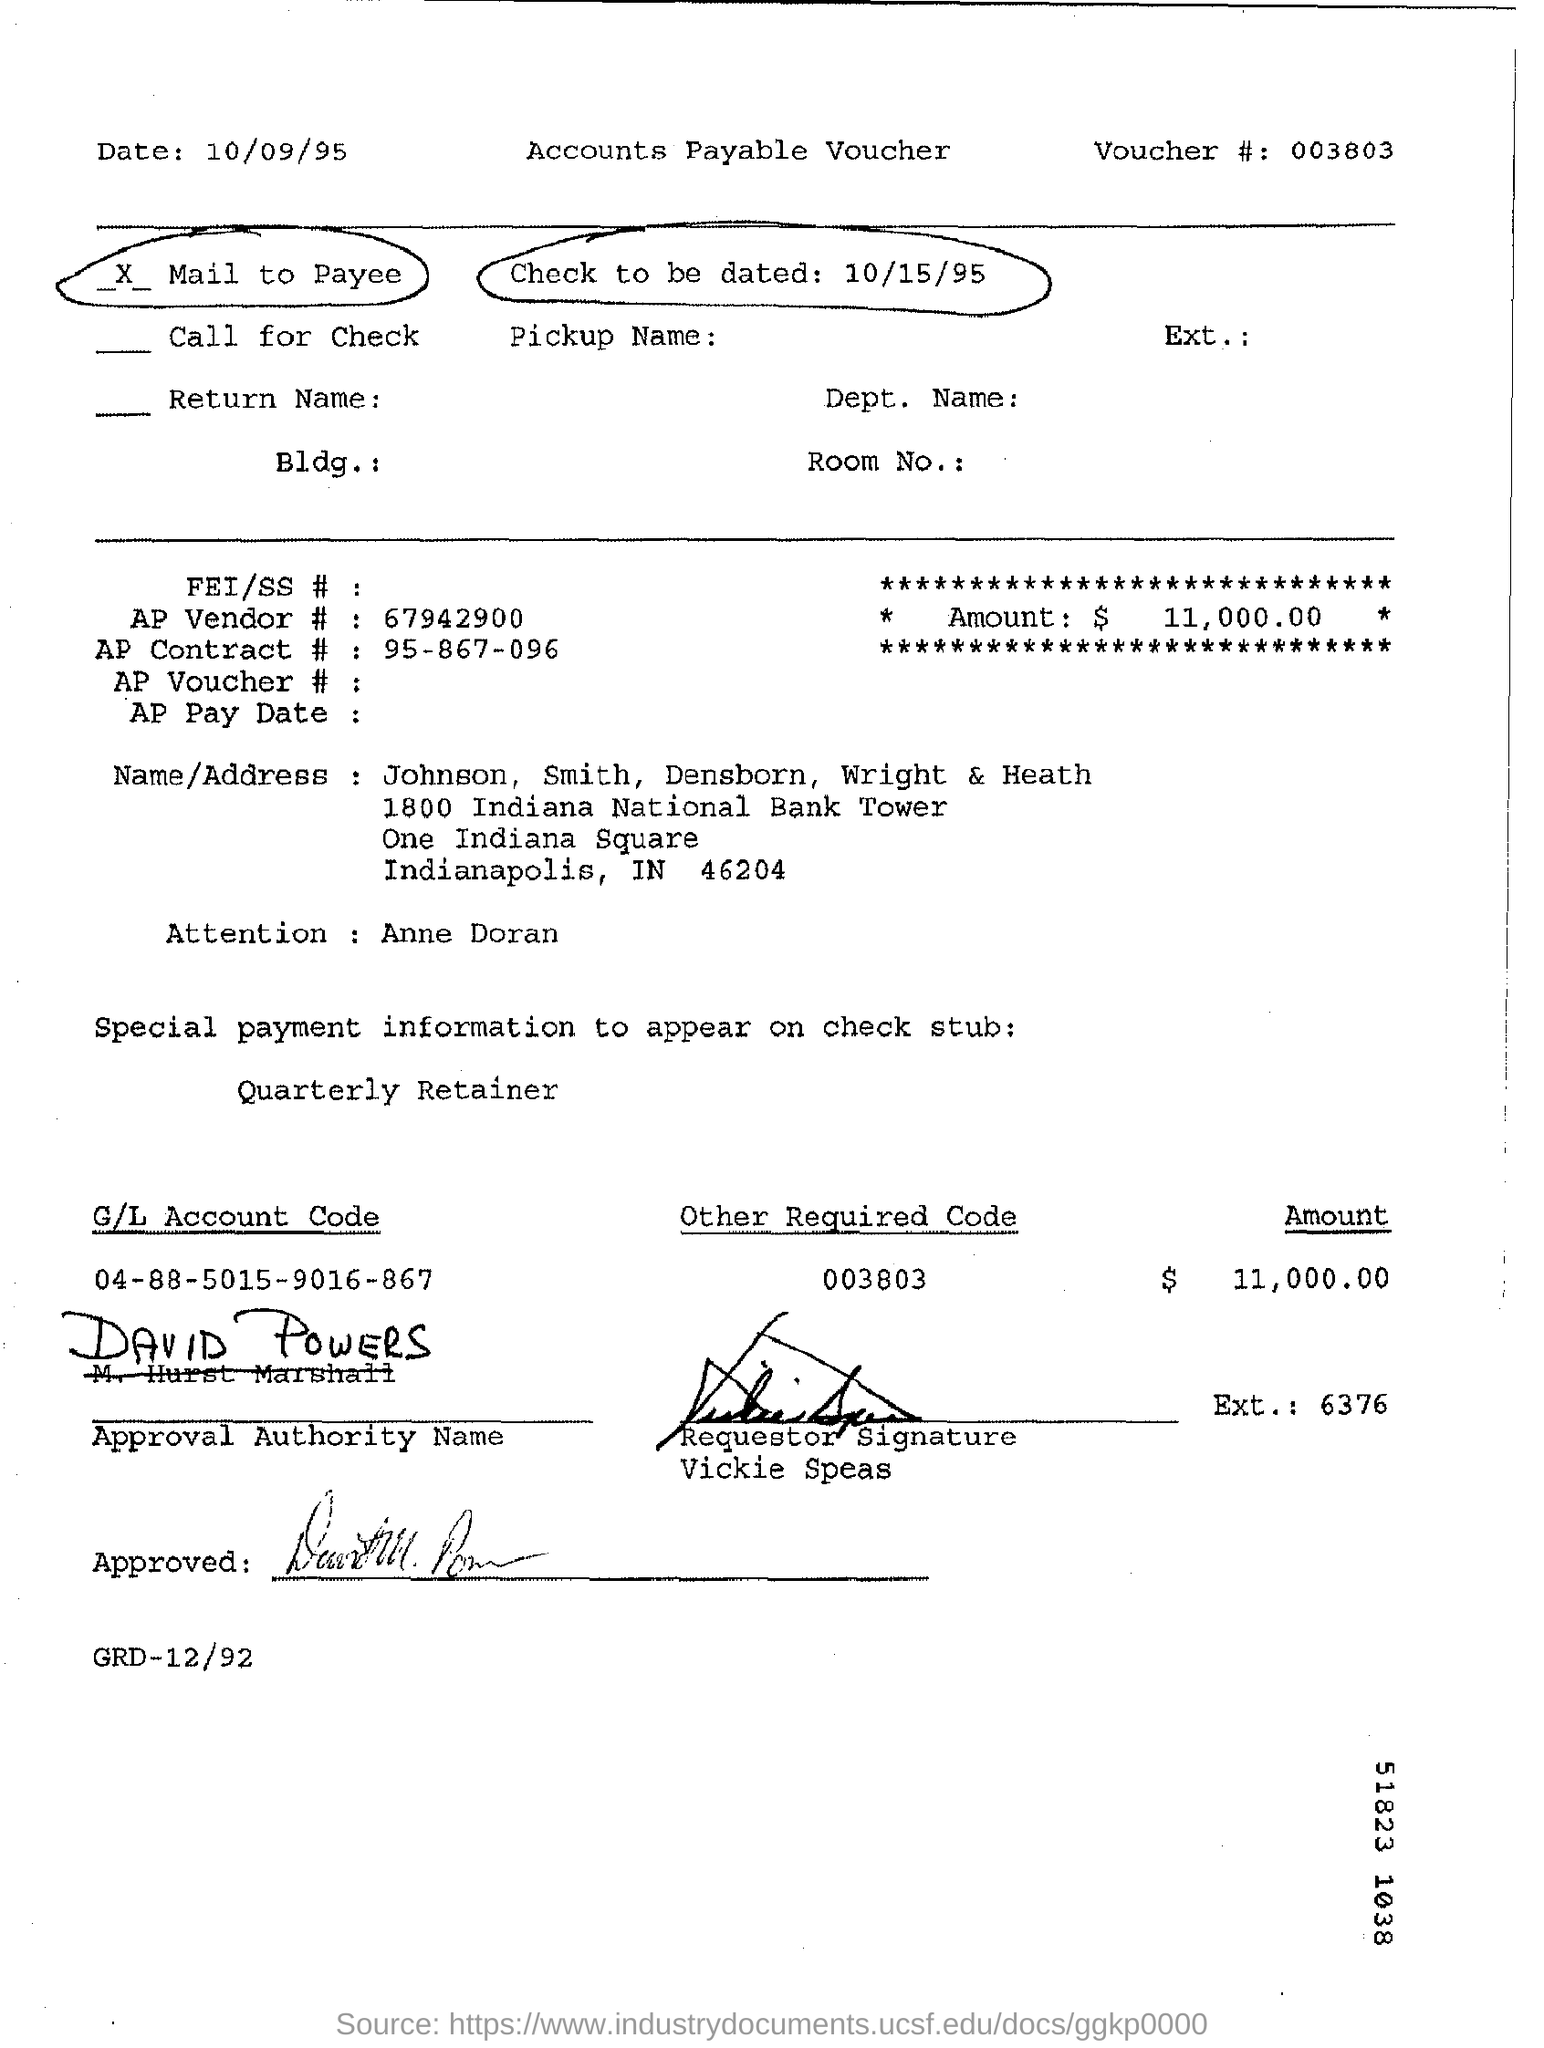When is the check to be dated?
Offer a very short reply. 10/15/95. What is the amount mentioned in the check?
Your answer should be very brief. $ 11,000.00. Who is the requestor?
Your answer should be compact. Vickie Speas. What is the voucher number?
Your answer should be very brief. 003803. What is the AP Contract # ?
Give a very brief answer. 95-867-096. 